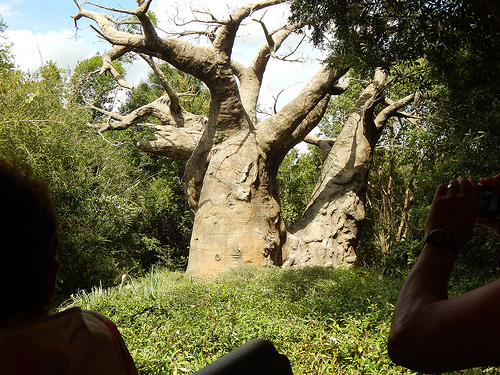<image>
Is the leaves on the branch? No. The leaves is not positioned on the branch. They may be near each other, but the leaves is not supported by or resting on top of the branch. 